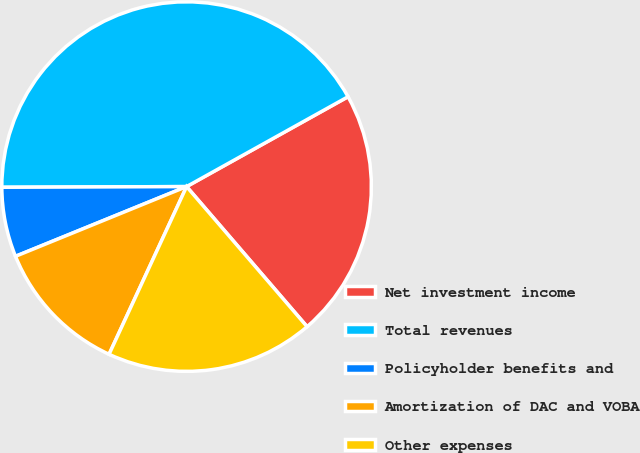<chart> <loc_0><loc_0><loc_500><loc_500><pie_chart><fcel>Net investment income<fcel>Total revenues<fcel>Policyholder benefits and<fcel>Amortization of DAC and VOBA<fcel>Other expenses<nl><fcel>21.78%<fcel>41.98%<fcel>6.1%<fcel>11.95%<fcel>18.2%<nl></chart> 